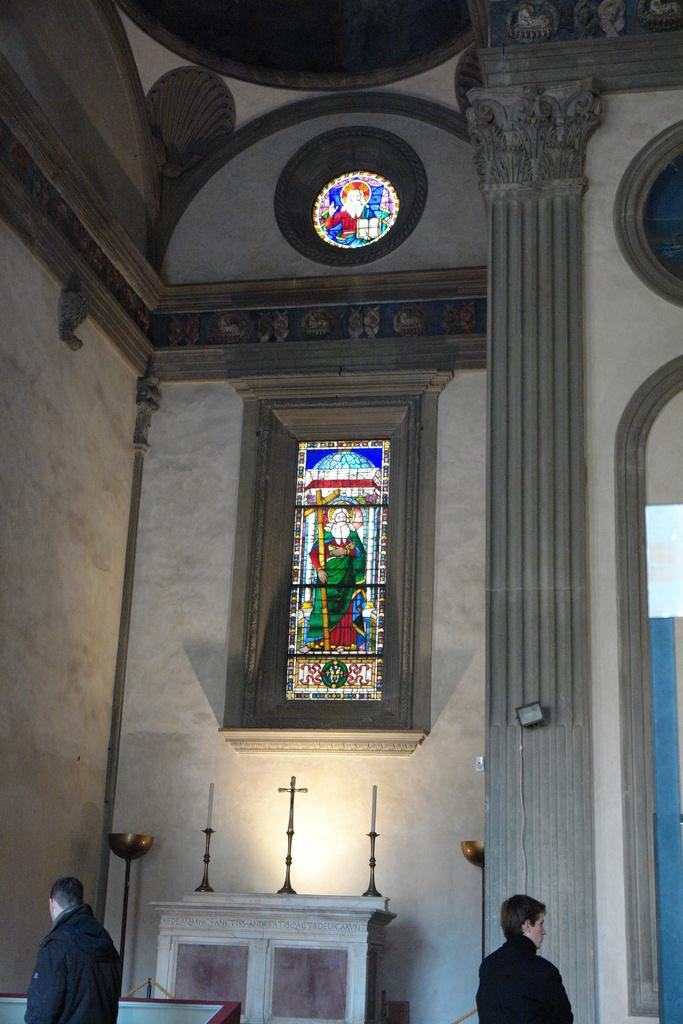What is located at the bottom of the image? There are persons and candles at the bottom of the image. What can be seen in the background of the image? There is stained glass and an arch in the background of the image. Can you see any feathers floating in the air in the image? There are no feathers visible in the image. Is the scene in the image taking place during winter? The provided facts do not mention any seasonal context, so it cannot be determined if the scene is taking place during winter. 